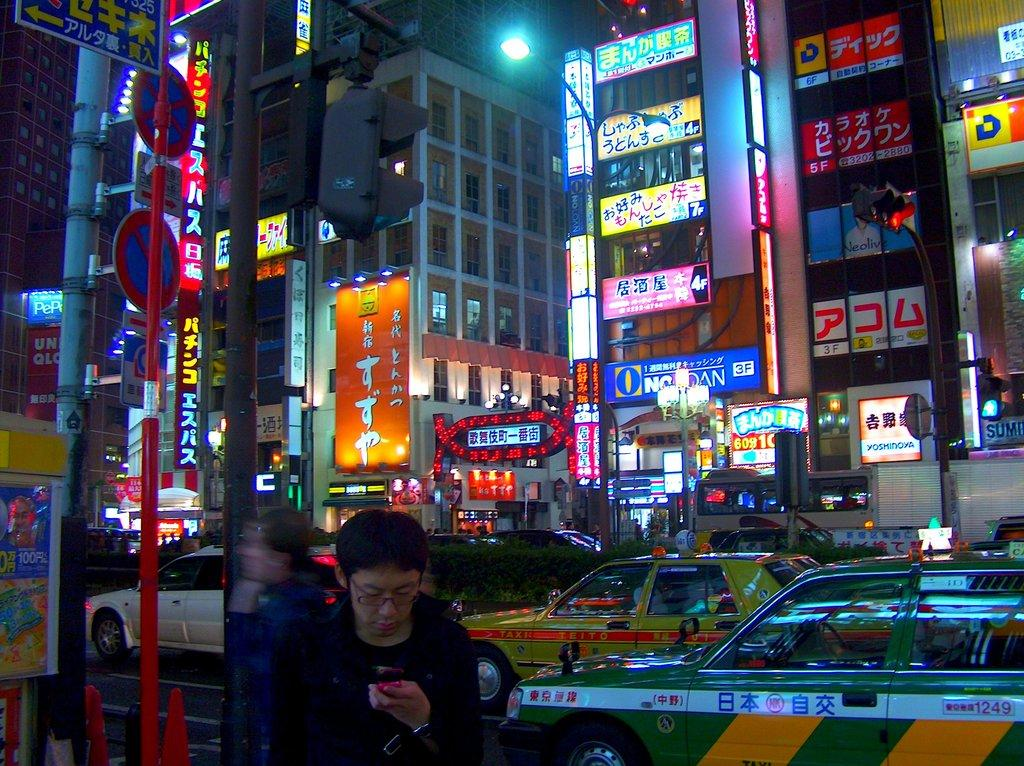<image>
Share a concise interpretation of the image provided. Taxis are driving past buildlings adorned with neon signs in Japan. 